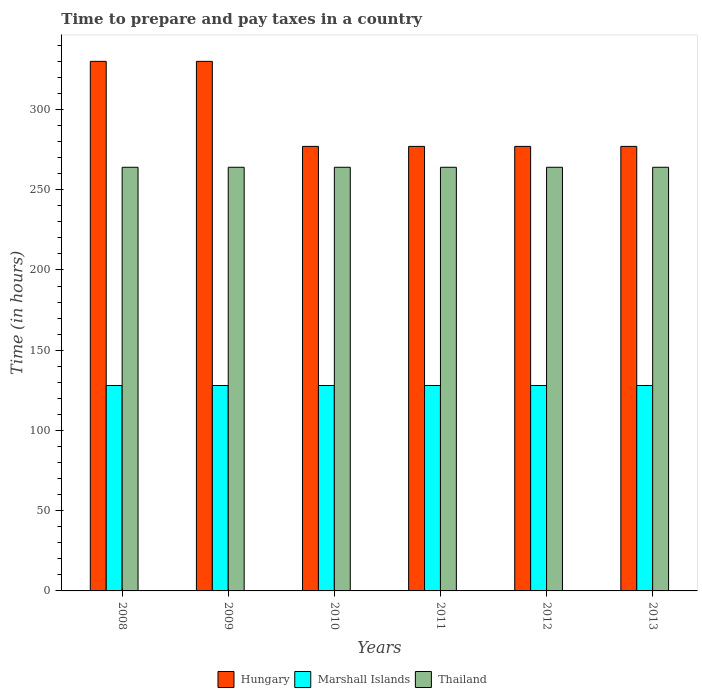How many different coloured bars are there?
Provide a short and direct response. 3. How many groups of bars are there?
Make the answer very short. 6. Are the number of bars on each tick of the X-axis equal?
Provide a short and direct response. Yes. How many bars are there on the 4th tick from the right?
Offer a terse response. 3. What is the label of the 5th group of bars from the left?
Provide a succinct answer. 2012. What is the number of hours required to prepare and pay taxes in Hungary in 2012?
Your response must be concise. 277. Across all years, what is the maximum number of hours required to prepare and pay taxes in Hungary?
Offer a very short reply. 330. Across all years, what is the minimum number of hours required to prepare and pay taxes in Marshall Islands?
Your answer should be very brief. 128. In which year was the number of hours required to prepare and pay taxes in Hungary minimum?
Make the answer very short. 2010. What is the total number of hours required to prepare and pay taxes in Thailand in the graph?
Provide a succinct answer. 1584. What is the difference between the number of hours required to prepare and pay taxes in Marshall Islands in 2009 and that in 2010?
Provide a succinct answer. 0. What is the difference between the number of hours required to prepare and pay taxes in Marshall Islands in 2010 and the number of hours required to prepare and pay taxes in Hungary in 2012?
Offer a very short reply. -149. What is the average number of hours required to prepare and pay taxes in Marshall Islands per year?
Your response must be concise. 128. In the year 2010, what is the difference between the number of hours required to prepare and pay taxes in Hungary and number of hours required to prepare and pay taxes in Thailand?
Give a very brief answer. 13. In how many years, is the number of hours required to prepare and pay taxes in Thailand greater than 40 hours?
Provide a succinct answer. 6. Is the difference between the number of hours required to prepare and pay taxes in Hungary in 2010 and 2013 greater than the difference between the number of hours required to prepare and pay taxes in Thailand in 2010 and 2013?
Offer a very short reply. No. What is the difference between the highest and the second highest number of hours required to prepare and pay taxes in Hungary?
Your answer should be compact. 0. What is the difference between the highest and the lowest number of hours required to prepare and pay taxes in Hungary?
Your response must be concise. 53. What does the 2nd bar from the left in 2009 represents?
Provide a succinct answer. Marshall Islands. What does the 1st bar from the right in 2010 represents?
Your response must be concise. Thailand. How many bars are there?
Give a very brief answer. 18. Are all the bars in the graph horizontal?
Give a very brief answer. No. What is the difference between two consecutive major ticks on the Y-axis?
Keep it short and to the point. 50. Does the graph contain any zero values?
Keep it short and to the point. No. Does the graph contain grids?
Ensure brevity in your answer.  No. How many legend labels are there?
Keep it short and to the point. 3. What is the title of the graph?
Your response must be concise. Time to prepare and pay taxes in a country. What is the label or title of the Y-axis?
Your response must be concise. Time (in hours). What is the Time (in hours) of Hungary in 2008?
Keep it short and to the point. 330. What is the Time (in hours) in Marshall Islands in 2008?
Provide a succinct answer. 128. What is the Time (in hours) in Thailand in 2008?
Provide a succinct answer. 264. What is the Time (in hours) of Hungary in 2009?
Ensure brevity in your answer.  330. What is the Time (in hours) in Marshall Islands in 2009?
Your answer should be very brief. 128. What is the Time (in hours) in Thailand in 2009?
Your response must be concise. 264. What is the Time (in hours) of Hungary in 2010?
Your answer should be compact. 277. What is the Time (in hours) in Marshall Islands in 2010?
Your response must be concise. 128. What is the Time (in hours) of Thailand in 2010?
Offer a very short reply. 264. What is the Time (in hours) of Hungary in 2011?
Make the answer very short. 277. What is the Time (in hours) of Marshall Islands in 2011?
Your answer should be very brief. 128. What is the Time (in hours) in Thailand in 2011?
Give a very brief answer. 264. What is the Time (in hours) of Hungary in 2012?
Your response must be concise. 277. What is the Time (in hours) in Marshall Islands in 2012?
Provide a succinct answer. 128. What is the Time (in hours) of Thailand in 2012?
Keep it short and to the point. 264. What is the Time (in hours) in Hungary in 2013?
Keep it short and to the point. 277. What is the Time (in hours) in Marshall Islands in 2013?
Make the answer very short. 128. What is the Time (in hours) of Thailand in 2013?
Provide a succinct answer. 264. Across all years, what is the maximum Time (in hours) of Hungary?
Keep it short and to the point. 330. Across all years, what is the maximum Time (in hours) in Marshall Islands?
Make the answer very short. 128. Across all years, what is the maximum Time (in hours) in Thailand?
Your response must be concise. 264. Across all years, what is the minimum Time (in hours) in Hungary?
Make the answer very short. 277. Across all years, what is the minimum Time (in hours) in Marshall Islands?
Ensure brevity in your answer.  128. Across all years, what is the minimum Time (in hours) in Thailand?
Your answer should be compact. 264. What is the total Time (in hours) in Hungary in the graph?
Provide a succinct answer. 1768. What is the total Time (in hours) in Marshall Islands in the graph?
Your answer should be compact. 768. What is the total Time (in hours) of Thailand in the graph?
Your answer should be compact. 1584. What is the difference between the Time (in hours) of Thailand in 2008 and that in 2009?
Provide a short and direct response. 0. What is the difference between the Time (in hours) of Hungary in 2008 and that in 2011?
Ensure brevity in your answer.  53. What is the difference between the Time (in hours) of Marshall Islands in 2008 and that in 2011?
Ensure brevity in your answer.  0. What is the difference between the Time (in hours) of Thailand in 2008 and that in 2011?
Make the answer very short. 0. What is the difference between the Time (in hours) in Marshall Islands in 2008 and that in 2012?
Your response must be concise. 0. What is the difference between the Time (in hours) in Thailand in 2008 and that in 2012?
Keep it short and to the point. 0. What is the difference between the Time (in hours) in Marshall Islands in 2008 and that in 2013?
Offer a terse response. 0. What is the difference between the Time (in hours) of Thailand in 2009 and that in 2010?
Ensure brevity in your answer.  0. What is the difference between the Time (in hours) of Hungary in 2009 and that in 2011?
Offer a terse response. 53. What is the difference between the Time (in hours) of Thailand in 2009 and that in 2011?
Offer a very short reply. 0. What is the difference between the Time (in hours) in Hungary in 2009 and that in 2012?
Keep it short and to the point. 53. What is the difference between the Time (in hours) in Thailand in 2009 and that in 2012?
Your answer should be compact. 0. What is the difference between the Time (in hours) in Marshall Islands in 2009 and that in 2013?
Give a very brief answer. 0. What is the difference between the Time (in hours) of Marshall Islands in 2010 and that in 2011?
Your response must be concise. 0. What is the difference between the Time (in hours) of Marshall Islands in 2010 and that in 2012?
Offer a very short reply. 0. What is the difference between the Time (in hours) in Hungary in 2010 and that in 2013?
Provide a succinct answer. 0. What is the difference between the Time (in hours) in Marshall Islands in 2010 and that in 2013?
Ensure brevity in your answer.  0. What is the difference between the Time (in hours) of Thailand in 2010 and that in 2013?
Keep it short and to the point. 0. What is the difference between the Time (in hours) in Hungary in 2011 and that in 2012?
Keep it short and to the point. 0. What is the difference between the Time (in hours) of Marshall Islands in 2011 and that in 2012?
Your response must be concise. 0. What is the difference between the Time (in hours) of Marshall Islands in 2011 and that in 2013?
Your answer should be compact. 0. What is the difference between the Time (in hours) of Thailand in 2011 and that in 2013?
Your answer should be very brief. 0. What is the difference between the Time (in hours) in Marshall Islands in 2012 and that in 2013?
Make the answer very short. 0. What is the difference between the Time (in hours) in Hungary in 2008 and the Time (in hours) in Marshall Islands in 2009?
Offer a very short reply. 202. What is the difference between the Time (in hours) of Hungary in 2008 and the Time (in hours) of Thailand in 2009?
Your answer should be very brief. 66. What is the difference between the Time (in hours) of Marshall Islands in 2008 and the Time (in hours) of Thailand in 2009?
Your answer should be very brief. -136. What is the difference between the Time (in hours) of Hungary in 2008 and the Time (in hours) of Marshall Islands in 2010?
Provide a short and direct response. 202. What is the difference between the Time (in hours) in Marshall Islands in 2008 and the Time (in hours) in Thailand in 2010?
Ensure brevity in your answer.  -136. What is the difference between the Time (in hours) of Hungary in 2008 and the Time (in hours) of Marshall Islands in 2011?
Provide a succinct answer. 202. What is the difference between the Time (in hours) in Marshall Islands in 2008 and the Time (in hours) in Thailand in 2011?
Offer a terse response. -136. What is the difference between the Time (in hours) of Hungary in 2008 and the Time (in hours) of Marshall Islands in 2012?
Give a very brief answer. 202. What is the difference between the Time (in hours) of Marshall Islands in 2008 and the Time (in hours) of Thailand in 2012?
Make the answer very short. -136. What is the difference between the Time (in hours) in Hungary in 2008 and the Time (in hours) in Marshall Islands in 2013?
Keep it short and to the point. 202. What is the difference between the Time (in hours) in Marshall Islands in 2008 and the Time (in hours) in Thailand in 2013?
Your answer should be very brief. -136. What is the difference between the Time (in hours) in Hungary in 2009 and the Time (in hours) in Marshall Islands in 2010?
Offer a terse response. 202. What is the difference between the Time (in hours) of Marshall Islands in 2009 and the Time (in hours) of Thailand in 2010?
Offer a terse response. -136. What is the difference between the Time (in hours) in Hungary in 2009 and the Time (in hours) in Marshall Islands in 2011?
Make the answer very short. 202. What is the difference between the Time (in hours) in Marshall Islands in 2009 and the Time (in hours) in Thailand in 2011?
Provide a succinct answer. -136. What is the difference between the Time (in hours) in Hungary in 2009 and the Time (in hours) in Marshall Islands in 2012?
Your response must be concise. 202. What is the difference between the Time (in hours) in Hungary in 2009 and the Time (in hours) in Thailand in 2012?
Your response must be concise. 66. What is the difference between the Time (in hours) of Marshall Islands in 2009 and the Time (in hours) of Thailand in 2012?
Offer a very short reply. -136. What is the difference between the Time (in hours) of Hungary in 2009 and the Time (in hours) of Marshall Islands in 2013?
Give a very brief answer. 202. What is the difference between the Time (in hours) in Hungary in 2009 and the Time (in hours) in Thailand in 2013?
Your answer should be very brief. 66. What is the difference between the Time (in hours) of Marshall Islands in 2009 and the Time (in hours) of Thailand in 2013?
Give a very brief answer. -136. What is the difference between the Time (in hours) in Hungary in 2010 and the Time (in hours) in Marshall Islands in 2011?
Provide a short and direct response. 149. What is the difference between the Time (in hours) in Hungary in 2010 and the Time (in hours) in Thailand in 2011?
Provide a succinct answer. 13. What is the difference between the Time (in hours) in Marshall Islands in 2010 and the Time (in hours) in Thailand in 2011?
Your answer should be very brief. -136. What is the difference between the Time (in hours) in Hungary in 2010 and the Time (in hours) in Marshall Islands in 2012?
Your answer should be very brief. 149. What is the difference between the Time (in hours) in Marshall Islands in 2010 and the Time (in hours) in Thailand in 2012?
Give a very brief answer. -136. What is the difference between the Time (in hours) in Hungary in 2010 and the Time (in hours) in Marshall Islands in 2013?
Give a very brief answer. 149. What is the difference between the Time (in hours) in Hungary in 2010 and the Time (in hours) in Thailand in 2013?
Give a very brief answer. 13. What is the difference between the Time (in hours) in Marshall Islands in 2010 and the Time (in hours) in Thailand in 2013?
Your answer should be compact. -136. What is the difference between the Time (in hours) of Hungary in 2011 and the Time (in hours) of Marshall Islands in 2012?
Offer a very short reply. 149. What is the difference between the Time (in hours) in Marshall Islands in 2011 and the Time (in hours) in Thailand in 2012?
Ensure brevity in your answer.  -136. What is the difference between the Time (in hours) in Hungary in 2011 and the Time (in hours) in Marshall Islands in 2013?
Provide a succinct answer. 149. What is the difference between the Time (in hours) in Hungary in 2011 and the Time (in hours) in Thailand in 2013?
Keep it short and to the point. 13. What is the difference between the Time (in hours) in Marshall Islands in 2011 and the Time (in hours) in Thailand in 2013?
Offer a terse response. -136. What is the difference between the Time (in hours) of Hungary in 2012 and the Time (in hours) of Marshall Islands in 2013?
Keep it short and to the point. 149. What is the difference between the Time (in hours) in Marshall Islands in 2012 and the Time (in hours) in Thailand in 2013?
Ensure brevity in your answer.  -136. What is the average Time (in hours) in Hungary per year?
Give a very brief answer. 294.67. What is the average Time (in hours) in Marshall Islands per year?
Your answer should be compact. 128. What is the average Time (in hours) in Thailand per year?
Make the answer very short. 264. In the year 2008, what is the difference between the Time (in hours) of Hungary and Time (in hours) of Marshall Islands?
Give a very brief answer. 202. In the year 2008, what is the difference between the Time (in hours) of Hungary and Time (in hours) of Thailand?
Provide a succinct answer. 66. In the year 2008, what is the difference between the Time (in hours) in Marshall Islands and Time (in hours) in Thailand?
Provide a succinct answer. -136. In the year 2009, what is the difference between the Time (in hours) in Hungary and Time (in hours) in Marshall Islands?
Make the answer very short. 202. In the year 2009, what is the difference between the Time (in hours) of Hungary and Time (in hours) of Thailand?
Your answer should be very brief. 66. In the year 2009, what is the difference between the Time (in hours) of Marshall Islands and Time (in hours) of Thailand?
Ensure brevity in your answer.  -136. In the year 2010, what is the difference between the Time (in hours) of Hungary and Time (in hours) of Marshall Islands?
Your answer should be very brief. 149. In the year 2010, what is the difference between the Time (in hours) of Marshall Islands and Time (in hours) of Thailand?
Your answer should be very brief. -136. In the year 2011, what is the difference between the Time (in hours) of Hungary and Time (in hours) of Marshall Islands?
Make the answer very short. 149. In the year 2011, what is the difference between the Time (in hours) of Marshall Islands and Time (in hours) of Thailand?
Make the answer very short. -136. In the year 2012, what is the difference between the Time (in hours) in Hungary and Time (in hours) in Marshall Islands?
Your answer should be very brief. 149. In the year 2012, what is the difference between the Time (in hours) in Marshall Islands and Time (in hours) in Thailand?
Provide a short and direct response. -136. In the year 2013, what is the difference between the Time (in hours) of Hungary and Time (in hours) of Marshall Islands?
Offer a terse response. 149. In the year 2013, what is the difference between the Time (in hours) in Marshall Islands and Time (in hours) in Thailand?
Offer a terse response. -136. What is the ratio of the Time (in hours) of Hungary in 2008 to that in 2009?
Provide a succinct answer. 1. What is the ratio of the Time (in hours) in Marshall Islands in 2008 to that in 2009?
Ensure brevity in your answer.  1. What is the ratio of the Time (in hours) in Thailand in 2008 to that in 2009?
Ensure brevity in your answer.  1. What is the ratio of the Time (in hours) of Hungary in 2008 to that in 2010?
Provide a short and direct response. 1.19. What is the ratio of the Time (in hours) of Marshall Islands in 2008 to that in 2010?
Keep it short and to the point. 1. What is the ratio of the Time (in hours) in Thailand in 2008 to that in 2010?
Provide a succinct answer. 1. What is the ratio of the Time (in hours) of Hungary in 2008 to that in 2011?
Give a very brief answer. 1.19. What is the ratio of the Time (in hours) of Marshall Islands in 2008 to that in 2011?
Keep it short and to the point. 1. What is the ratio of the Time (in hours) of Thailand in 2008 to that in 2011?
Your answer should be very brief. 1. What is the ratio of the Time (in hours) of Hungary in 2008 to that in 2012?
Keep it short and to the point. 1.19. What is the ratio of the Time (in hours) in Marshall Islands in 2008 to that in 2012?
Your answer should be compact. 1. What is the ratio of the Time (in hours) in Thailand in 2008 to that in 2012?
Provide a short and direct response. 1. What is the ratio of the Time (in hours) in Hungary in 2008 to that in 2013?
Ensure brevity in your answer.  1.19. What is the ratio of the Time (in hours) of Marshall Islands in 2008 to that in 2013?
Provide a succinct answer. 1. What is the ratio of the Time (in hours) of Thailand in 2008 to that in 2013?
Your answer should be very brief. 1. What is the ratio of the Time (in hours) of Hungary in 2009 to that in 2010?
Your answer should be compact. 1.19. What is the ratio of the Time (in hours) in Marshall Islands in 2009 to that in 2010?
Offer a very short reply. 1. What is the ratio of the Time (in hours) of Hungary in 2009 to that in 2011?
Your answer should be compact. 1.19. What is the ratio of the Time (in hours) of Thailand in 2009 to that in 2011?
Offer a very short reply. 1. What is the ratio of the Time (in hours) of Hungary in 2009 to that in 2012?
Your answer should be compact. 1.19. What is the ratio of the Time (in hours) in Thailand in 2009 to that in 2012?
Your answer should be very brief. 1. What is the ratio of the Time (in hours) in Hungary in 2009 to that in 2013?
Provide a short and direct response. 1.19. What is the ratio of the Time (in hours) of Hungary in 2010 to that in 2012?
Provide a succinct answer. 1. What is the ratio of the Time (in hours) of Marshall Islands in 2010 to that in 2012?
Offer a terse response. 1. What is the ratio of the Time (in hours) of Thailand in 2010 to that in 2012?
Provide a succinct answer. 1. What is the ratio of the Time (in hours) of Hungary in 2010 to that in 2013?
Offer a very short reply. 1. What is the ratio of the Time (in hours) of Marshall Islands in 2010 to that in 2013?
Offer a very short reply. 1. What is the ratio of the Time (in hours) of Hungary in 2011 to that in 2012?
Provide a short and direct response. 1. What is the ratio of the Time (in hours) of Hungary in 2011 to that in 2013?
Your response must be concise. 1. What is the ratio of the Time (in hours) in Thailand in 2011 to that in 2013?
Your answer should be compact. 1. What is the ratio of the Time (in hours) in Hungary in 2012 to that in 2013?
Provide a succinct answer. 1. What is the ratio of the Time (in hours) in Marshall Islands in 2012 to that in 2013?
Keep it short and to the point. 1. What is the ratio of the Time (in hours) in Thailand in 2012 to that in 2013?
Make the answer very short. 1. What is the difference between the highest and the second highest Time (in hours) in Hungary?
Your answer should be compact. 0. 